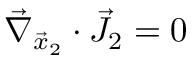<formula> <loc_0><loc_0><loc_500><loc_500>\vec { \nabla } _ { \vec { x } _ { 2 } } \cdot \vec { J } _ { 2 } = 0</formula> 